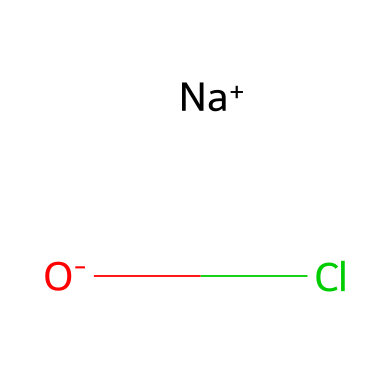What is the molecular formula of sodium hypochlorite? The SMILES representation shows that sodium (Na), oxygen (O), and chlorine (Cl) are present. The count of each atom gives us the molecular formula NaOCl, indicating one sodium atom, one oxygen atom, and one chlorine atom.
Answer: NaOCl How many atoms are in the sodium hypochlorite molecule? By counting the components in the SMILES representation, there are three distinct atoms: one sodium, one oxygen, and one chlorine. Therefore, the total number of atoms is three.
Answer: 3 What charge does the sodium ion carry in sodium hypochlorite? The [Na+] notation in the SMILES indicates that the sodium ion has a positive charge, which is common for alkali metals.
Answer: positive What type of bond exists between sodium and hypochlorite in this compound? The structure reveals that sodium and the hypochlorite ion are associated through ionic bonding. Sodium is a cation ([Na+]) and hypochlorite contains an anionic part ([O-]Cl), thus indicating an ionic bond.
Answer: ionic What is the oxidation state of chlorine in sodium hypochlorite? In sodium hypochlorite, the chlorine atom is bonded to a negatively charged oxygen and a positively charged sodium. Typically, chlorine in hypochlorite has an oxidation state of +1, which can be derived from balancing the charges in the overall compound.
Answer: +1 Is sodium hypochlorite a strong or weak oxidizing agent? Sodium hypochlorite, due to its chlorine content and structure, acts as a strong oxidizing agent, which is evident in its reactivity and usage in sanitation.
Answer: strong How does the presence of the oxygen atom influence the properties of sodium hypochlorite? The oxygen atom in sodium hypochlorite contributes to its oxidizing properties and stability as a bleach. It forms part of the hypochlorite ion (OCl-) and enhances the molecule's ability to donate oxygen, making it effective in sanitation applications.
Answer: increases oxidizing properties 